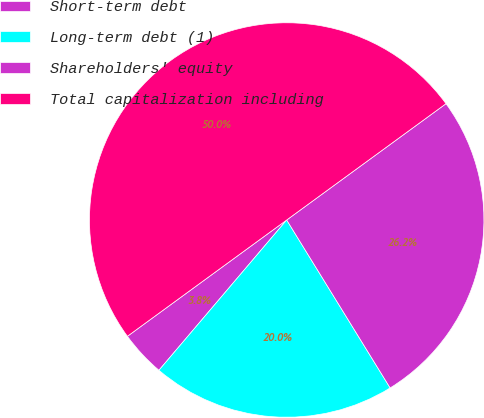Convert chart. <chart><loc_0><loc_0><loc_500><loc_500><pie_chart><fcel>Short-term debt<fcel>Long-term debt (1)<fcel>Shareholders' equity<fcel>Total capitalization including<nl><fcel>3.75%<fcel>20.0%<fcel>26.25%<fcel>50.0%<nl></chart> 